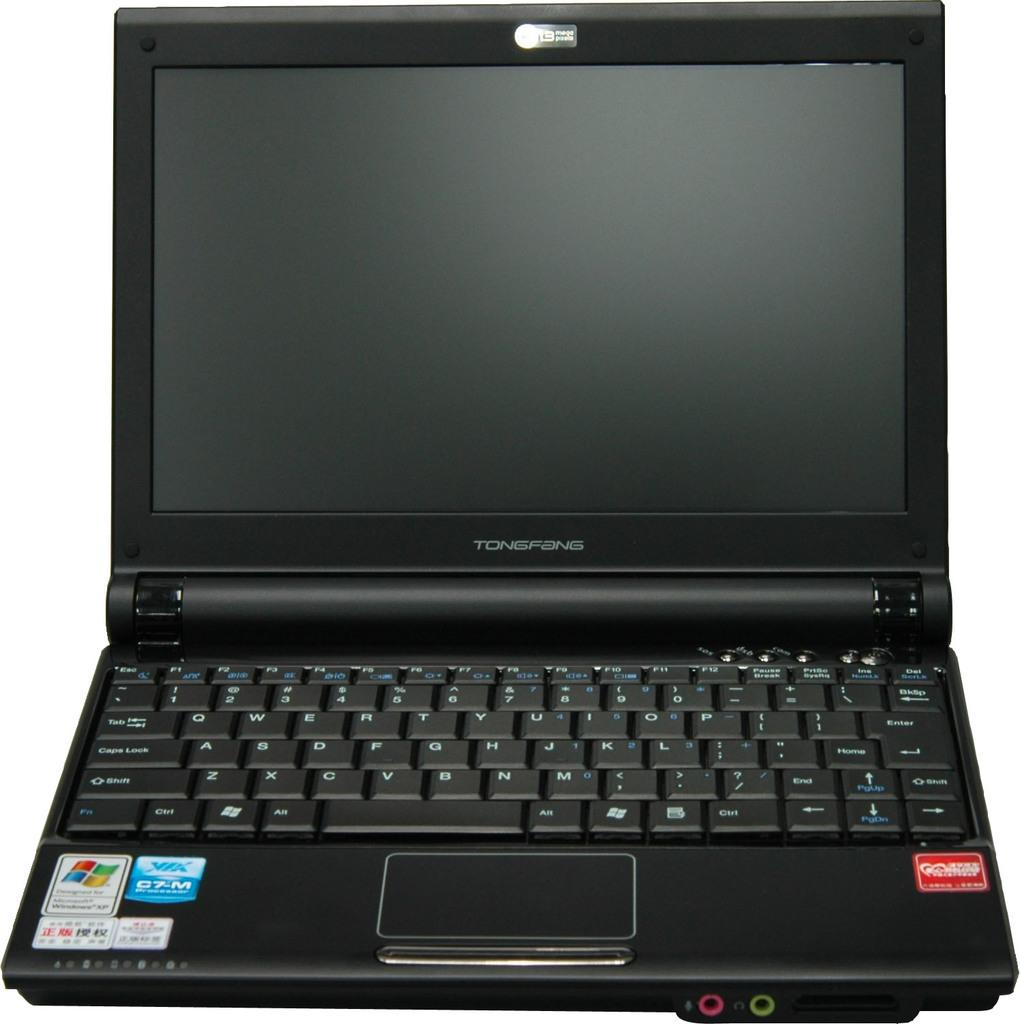Provide a one-sentence caption for the provided image. A Tongfang laptop computer is open but shut off. 